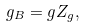<formula> <loc_0><loc_0><loc_500><loc_500>g _ { B } = g Z _ { g } ,</formula> 